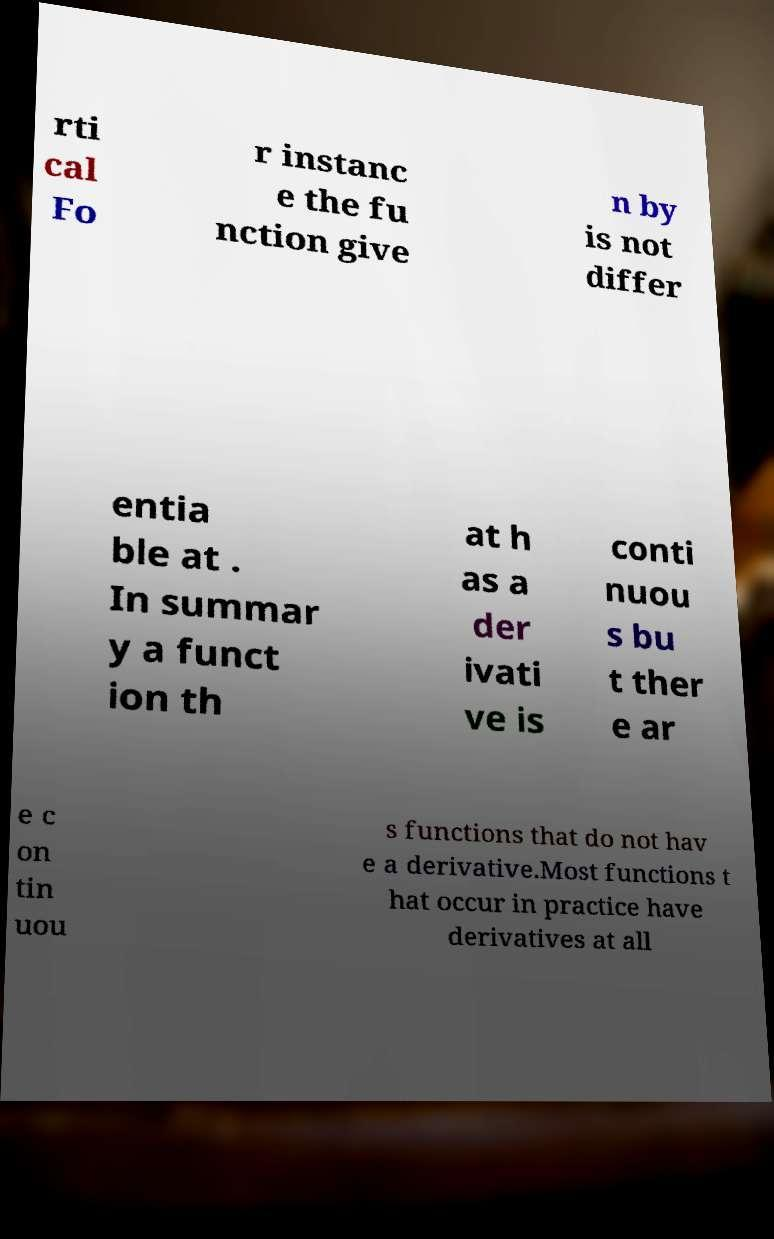Can you accurately transcribe the text from the provided image for me? rti cal Fo r instanc e the fu nction give n by is not differ entia ble at . In summar y a funct ion th at h as a der ivati ve is conti nuou s bu t ther e ar e c on tin uou s functions that do not hav e a derivative.Most functions t hat occur in practice have derivatives at all 